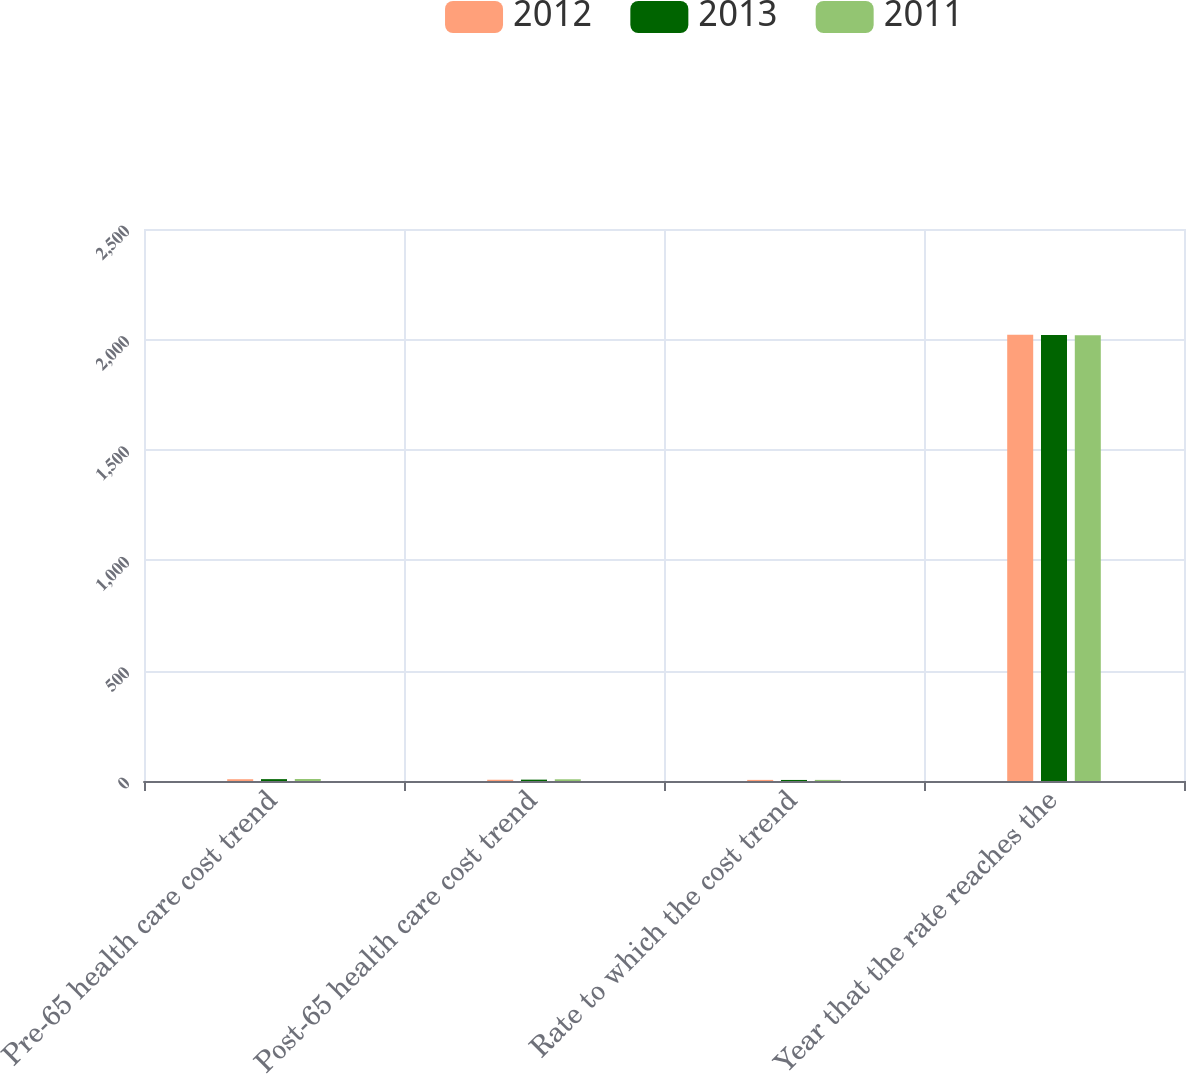Convert chart to OTSL. <chart><loc_0><loc_0><loc_500><loc_500><stacked_bar_chart><ecel><fcel>Pre-65 health care cost trend<fcel>Post-65 health care cost trend<fcel>Rate to which the cost trend<fcel>Year that the rate reaches the<nl><fcel>2012<fcel>8.05<fcel>5.7<fcel>5<fcel>2021<nl><fcel>2013<fcel>8.45<fcel>6.15<fcel>4.75<fcel>2020<nl><fcel>2011<fcel>8.95<fcel>7.75<fcel>5<fcel>2019<nl></chart> 